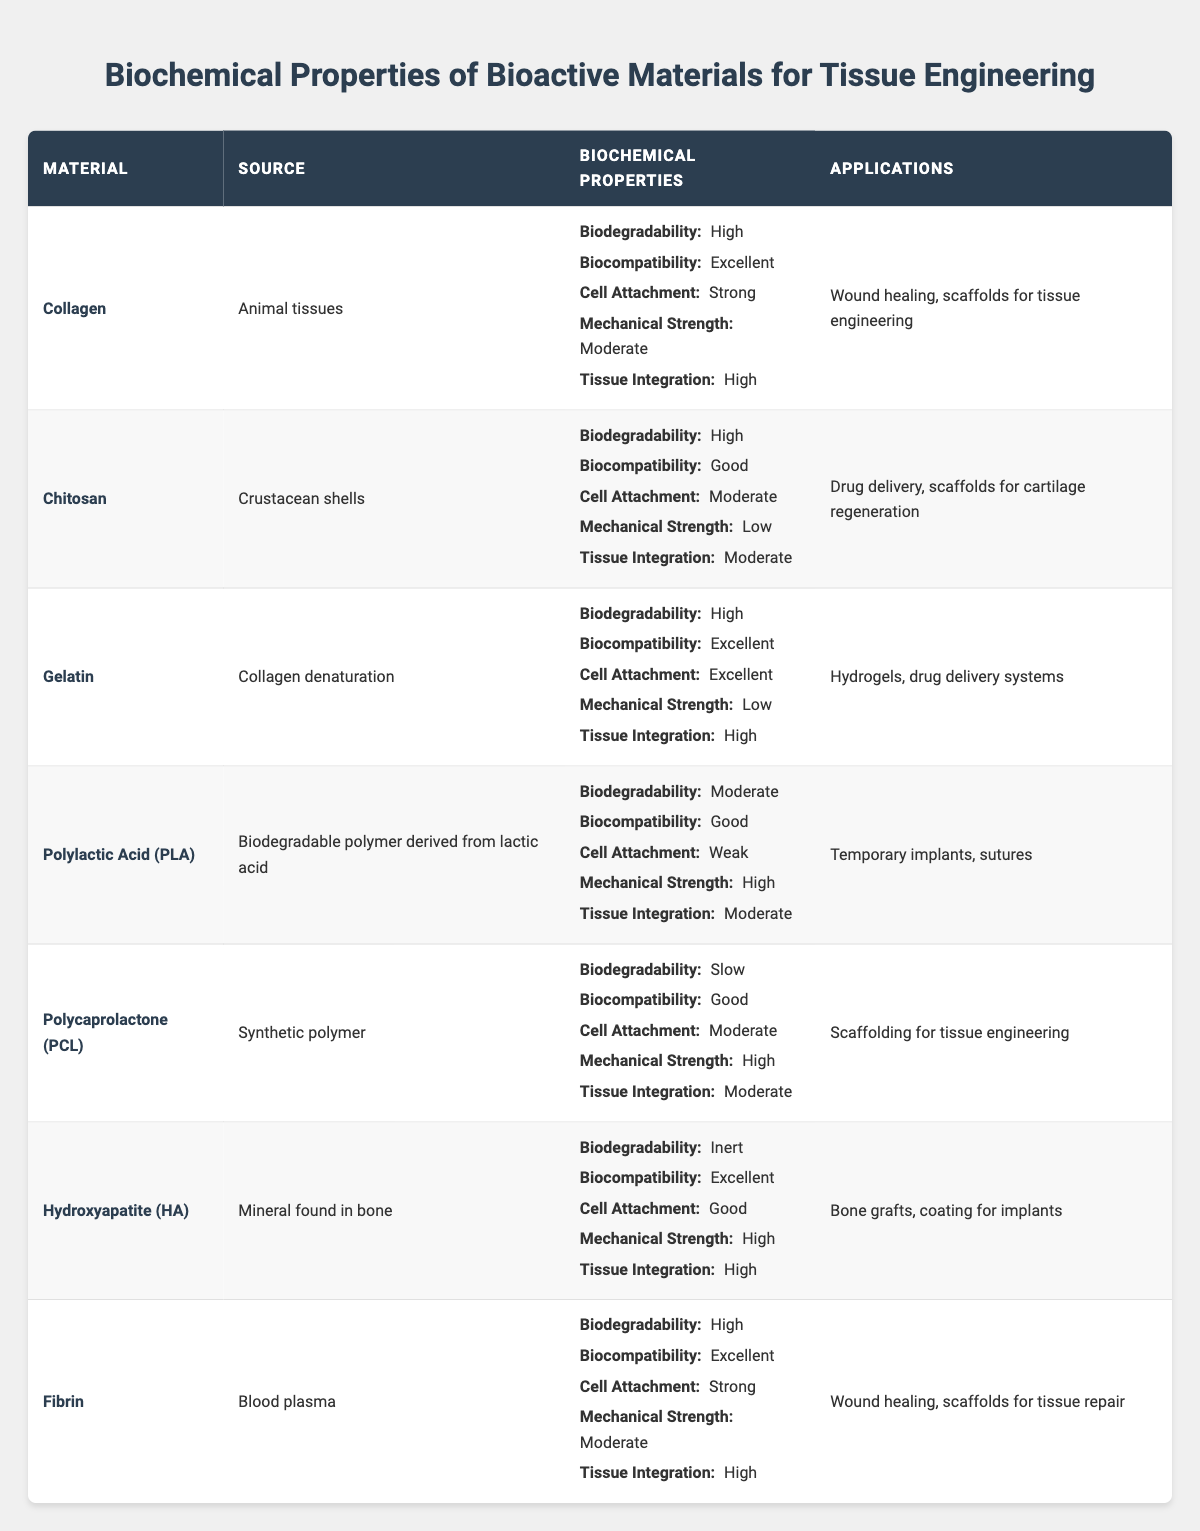What is the source of Hydroxyapatite? Hydroxyapatite (HA) is listed in the table, and under the "Source" column, it states that its source is "Mineral found in bone."
Answer: Mineral found in bone Which material has the highest mechanical strength? By examining the "Mechanical Strength" values across all materials, both Polylactic Acid (PLA), Polycaprolactone (PCL), and Hydroxyapatite (HA) have "High" strength. However, when looking at the unique maximum value, it's represented by PLA, PCL, and HA.
Answer: Polylactic Acid (PLA), Polycaprolactone (PCL), and Hydroxyapatite (HA) (all have high) Is Gelatin biodegradable? The table indicates that Gelatin has "High" biodegradability in the "Biochemical Properties" section.
Answer: Yes What percentage of materials have excellent biocompatibility? There are 3 materials (Collagen, Gelatin, and Hydroxyapatite) that have "Excellent" biocompatibility out of a total of 7 materials, so the percentage is calculated as (3/7)*100 ≈ 42.86%.
Answer: Approximately 42.86% Does Chitosan have stronger cell attachment than Collagen? Reviewing the cell attachment ratings, Chitosan has "Moderate" attachment while Collagen has "Strong" attachment. Therefore, Collagen has stronger cell attachment than Chitosan.
Answer: No Which material is used in drug delivery systems? The table notes that Gelatin is used for "Hydrogels, drug delivery systems" under the "Applications" column.
Answer: Gelatin How do the tissue integration ratings of Collagen and Fibrin compare? Both Collagen and Fibrin have "High" ratings for tissue integration according to the "Biochemical Properties" column, indicating they have the same level of integration.
Answer: They are the same (both high) Which material has the lowest cell attachment rating? The table shows that Polylactic Acid (PLA) has a "Weak" cell attachment rating, which is the lowest among all listed materials.
Answer: Polylactic Acid (PLA) Which two materials have the same biodegradability rating? Examining the "Biodegradability" for each material, both Gelatin and Collagen have a "High" rating, while Hydroxyapatite has "Inert." Thus, Gelatin and Collagen share the same rating.
Answer: Gelatin and Collagen How many materials are suitable for scaffolding applications? The applications column states that Collagen, Chitosan, Polycaprolactone (PCL), and Hydroxyapatite are suitable, giving a total count of 4 materials used for scaffolding.
Answer: 4 materials 